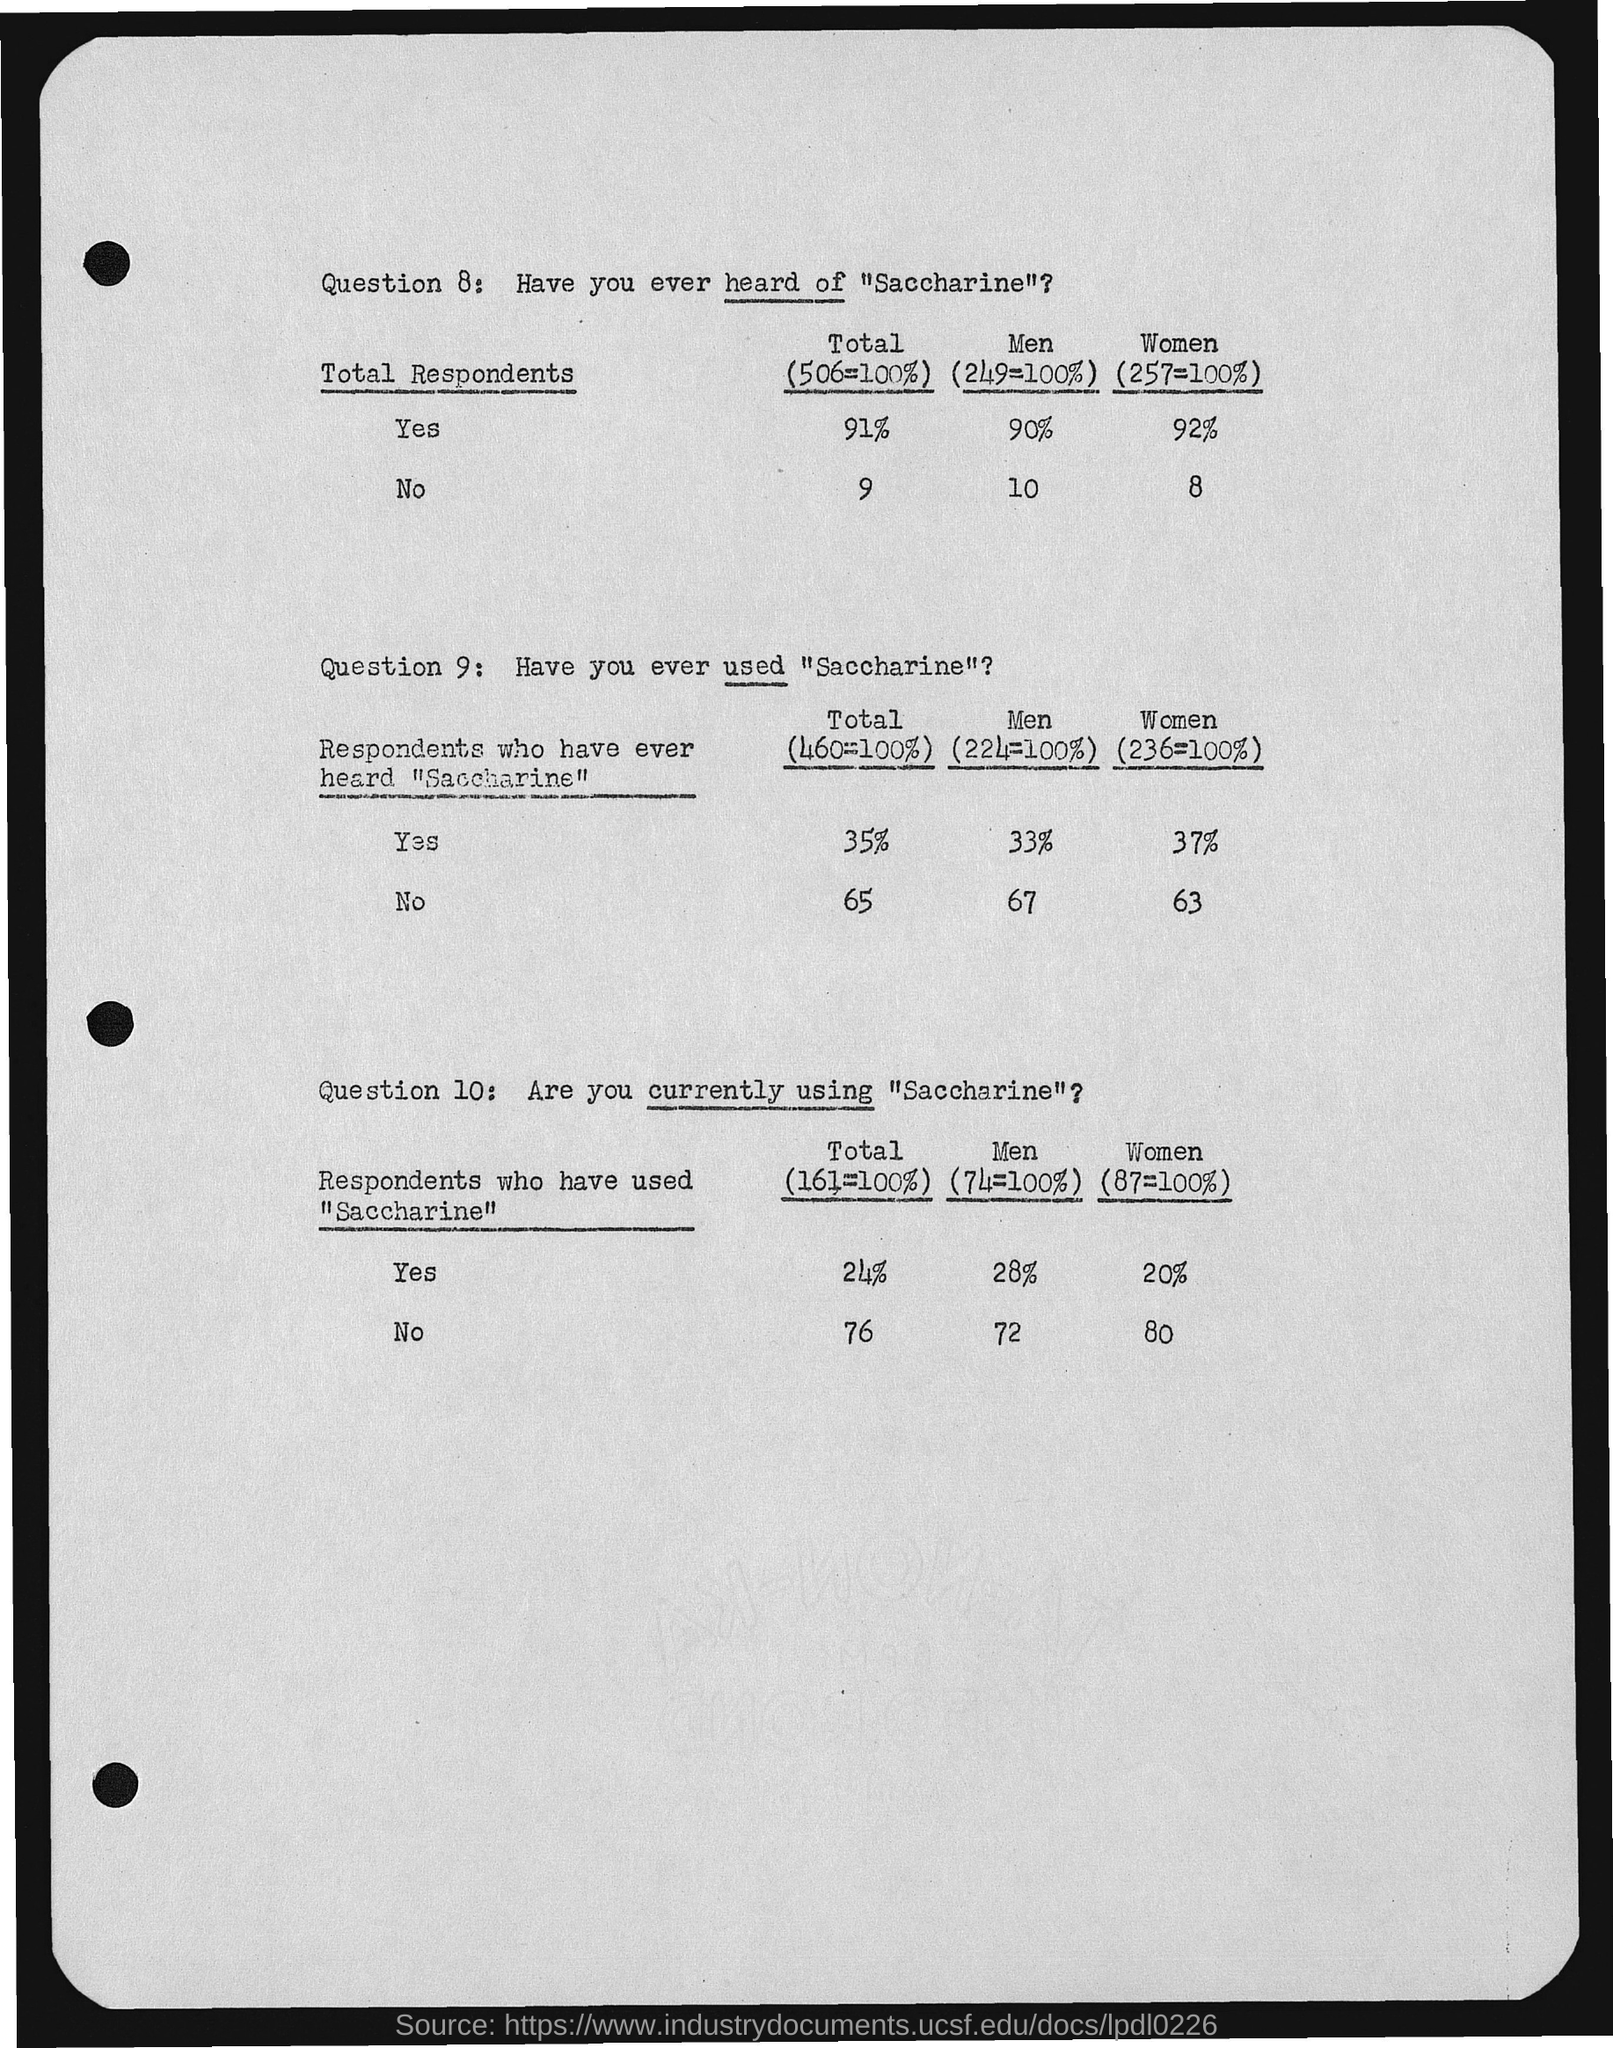What is the Total (506=100%) who said Yes?
Offer a terse response. 91%. What is the Men (249=100%) who said Yes?
Your response must be concise. 90%. What is the Women (257=100%) who said Yes?
Ensure brevity in your answer.  92. What is the Total (506=100%) who said No?
Make the answer very short. 9. What is the Men (249=100%) who said No?
Ensure brevity in your answer.  10. What is the Women (257=100%) who said No?
Give a very brief answer. 8. 